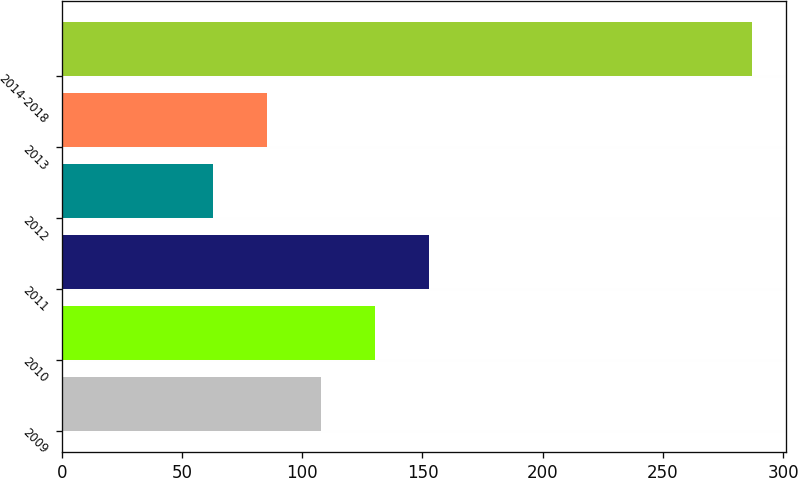<chart> <loc_0><loc_0><loc_500><loc_500><bar_chart><fcel>2009<fcel>2010<fcel>2011<fcel>2012<fcel>2013<fcel>2014-2018<nl><fcel>107.8<fcel>130.2<fcel>152.6<fcel>63<fcel>85.4<fcel>287<nl></chart> 